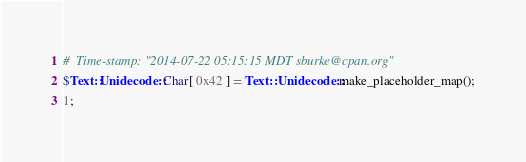Convert code to text. <code><loc_0><loc_0><loc_500><loc_500><_Perl_>#  Time-stamp: "2014-07-22 05:15:15 MDT sburke@cpan.org"
$Text::Unidecode::Char[ 0x42 ] = Text::Unidecode::make_placeholder_map();
1;
</code> 